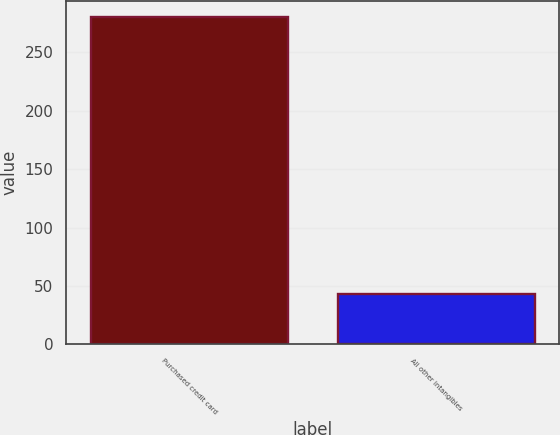<chart> <loc_0><loc_0><loc_500><loc_500><bar_chart><fcel>Purchased credit card<fcel>All other intangibles<nl><fcel>280<fcel>43<nl></chart> 